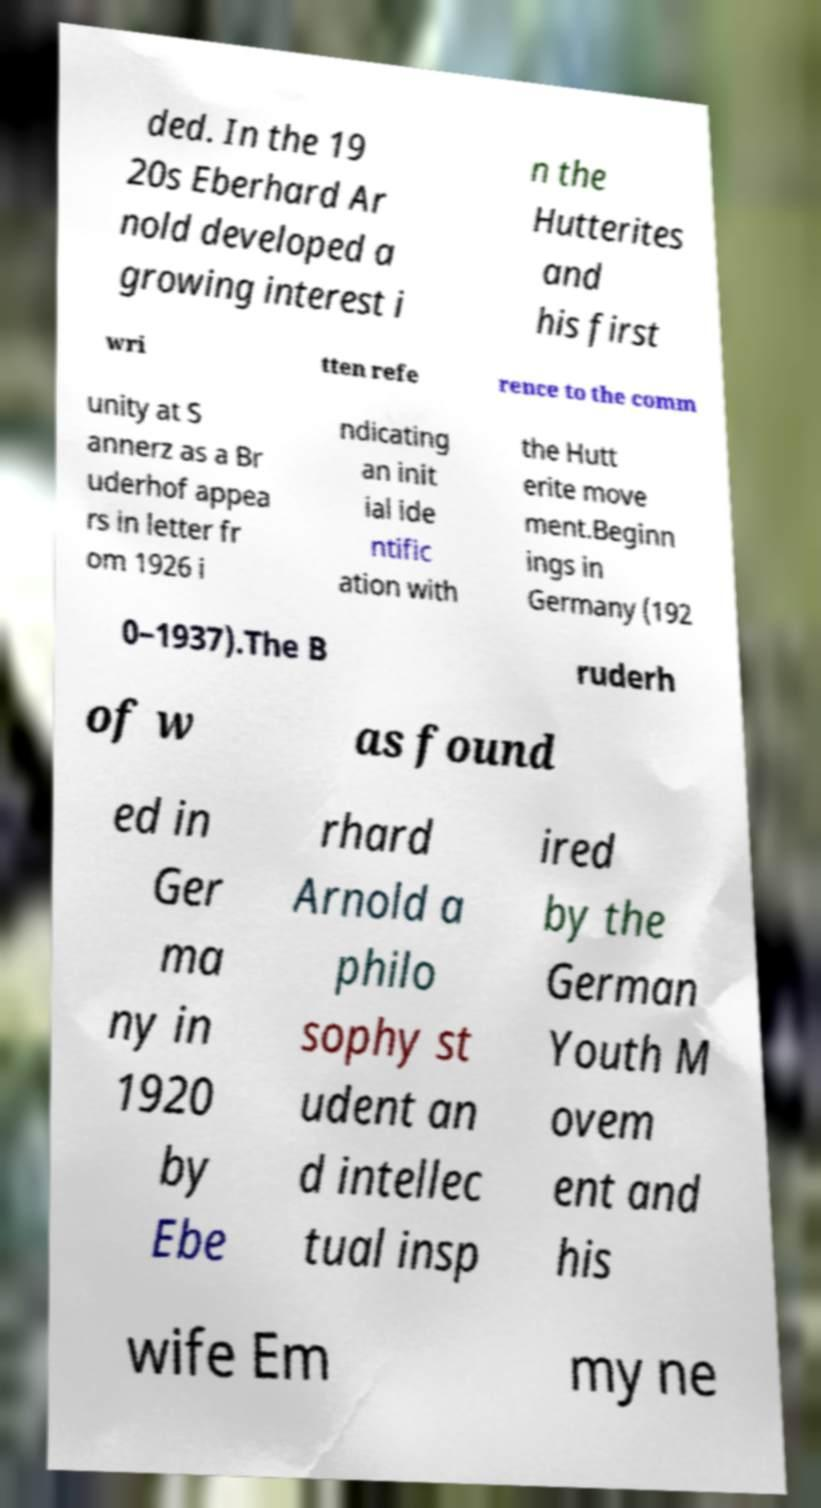For documentation purposes, I need the text within this image transcribed. Could you provide that? ded. In the 19 20s Eberhard Ar nold developed a growing interest i n the Hutterites and his first wri tten refe rence to the comm unity at S annerz as a Br uderhof appea rs in letter fr om 1926 i ndicating an init ial ide ntific ation with the Hutt erite move ment.Beginn ings in Germany (192 0–1937).The B ruderh of w as found ed in Ger ma ny in 1920 by Ebe rhard Arnold a philo sophy st udent an d intellec tual insp ired by the German Youth M ovem ent and his wife Em my ne 